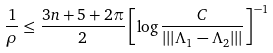<formula> <loc_0><loc_0><loc_500><loc_500>\frac { 1 } { \rho } \leq \frac { 3 n + 5 + 2 \pi } { 2 } \left [ \log \frac { C } { | | | \Lambda _ { 1 } - \Lambda _ { 2 } | | | } \right ] ^ { - 1 }</formula> 